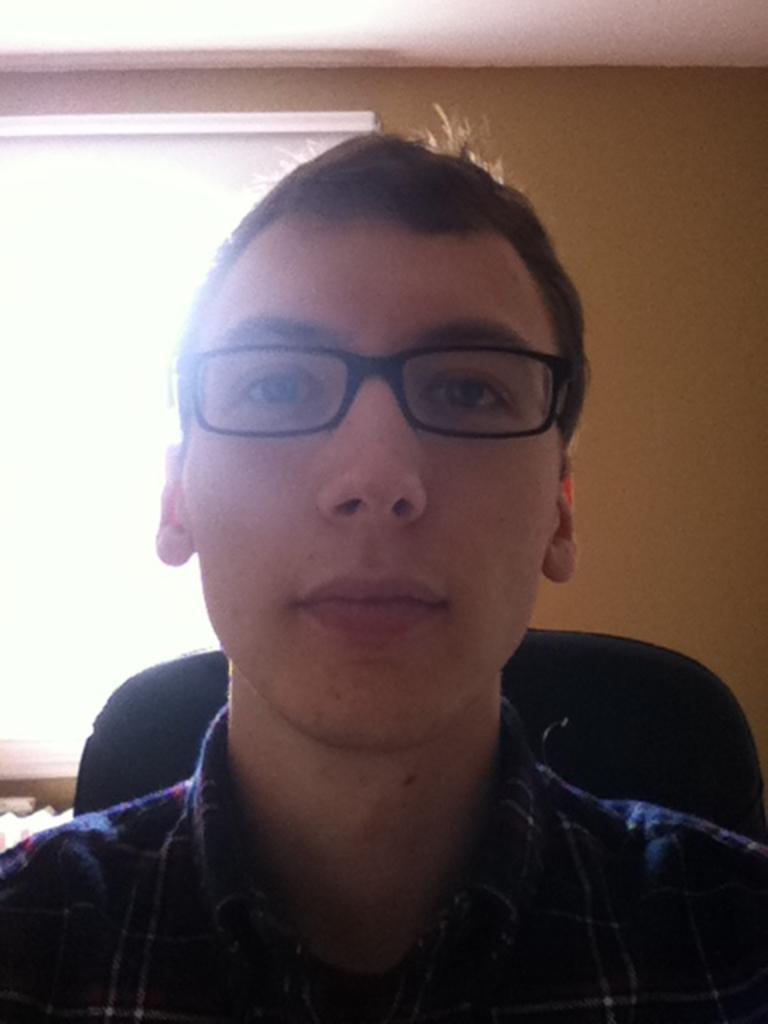How would you summarize this image in a sentence or two? In this image there is a person wearing specs and sitting on a chair which is black in colour. In the background there is a window. 